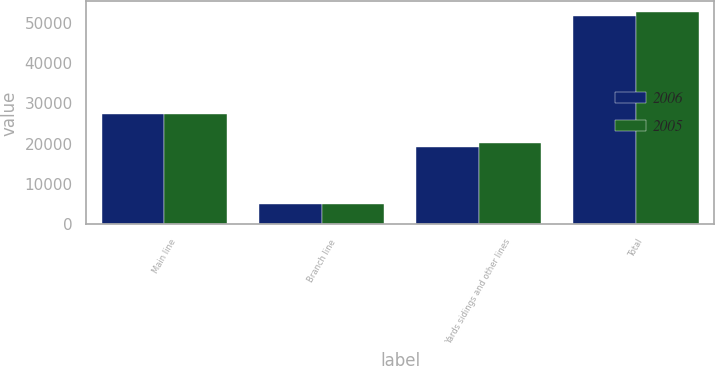<chart> <loc_0><loc_0><loc_500><loc_500><stacked_bar_chart><ecel><fcel>Main line<fcel>Branch line<fcel>Yards sidings and other lines<fcel>Total<nl><fcel>2006<fcel>27318<fcel>5021<fcel>19257<fcel>51596<nl><fcel>2005<fcel>27301<fcel>5125<fcel>20241<fcel>52667<nl></chart> 